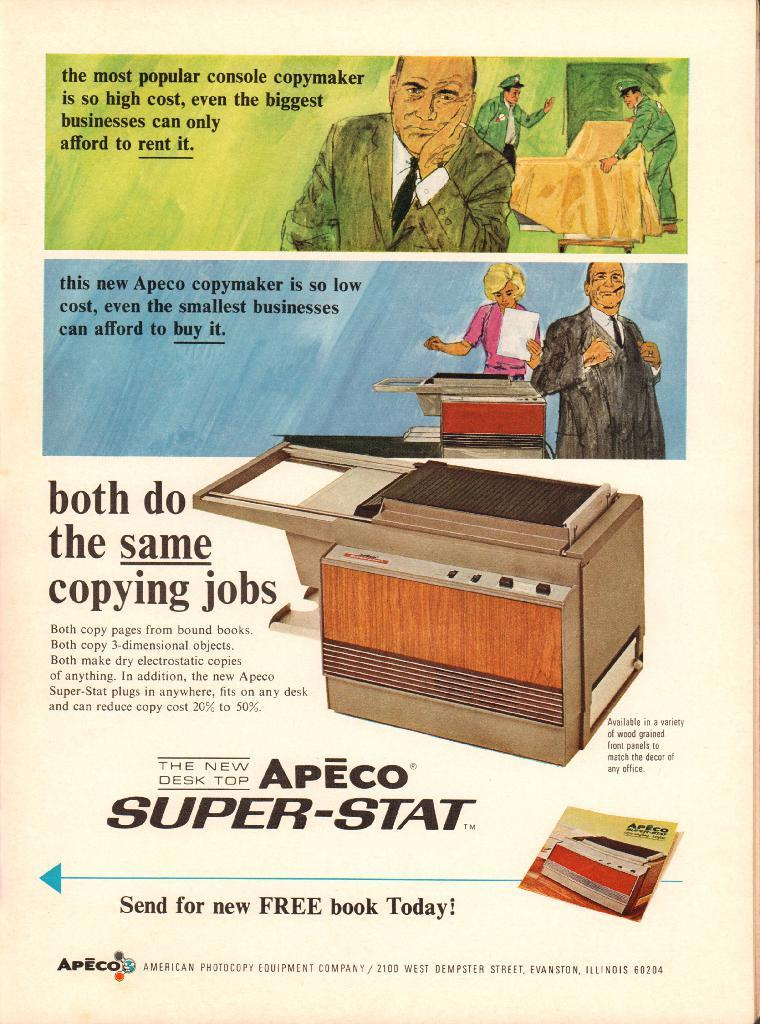<image>
Relay a brief, clear account of the picture shown. an advertisement for the apeco super stat copier 